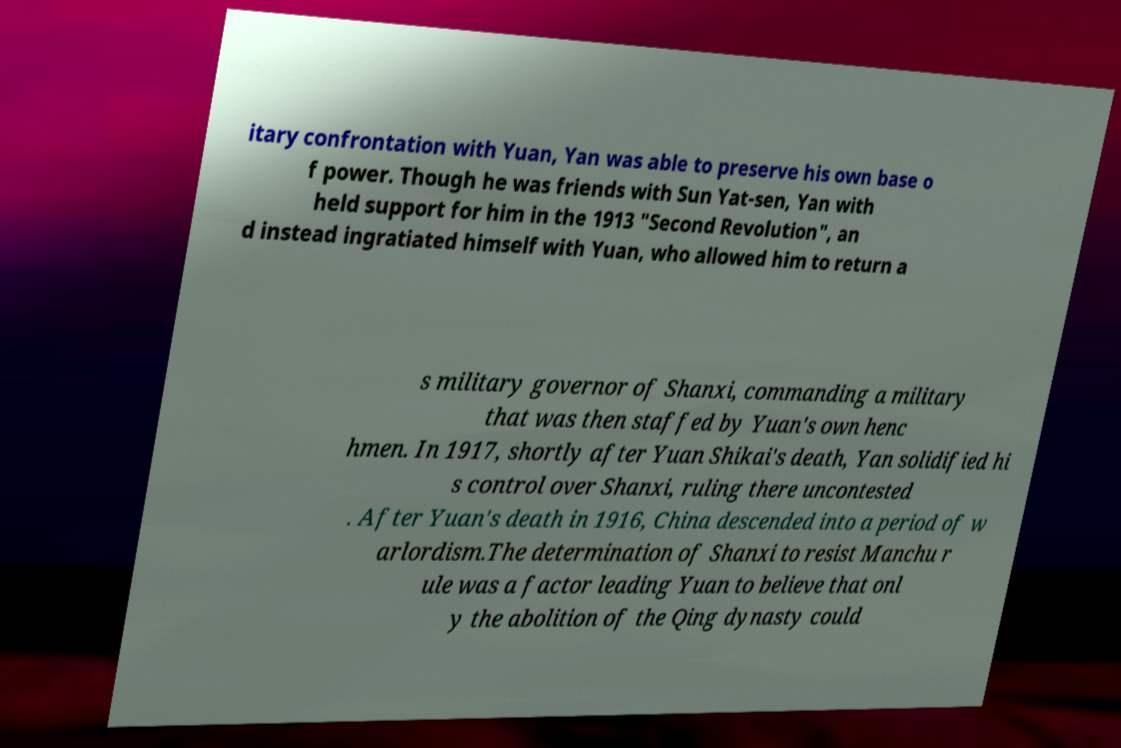There's text embedded in this image that I need extracted. Can you transcribe it verbatim? itary confrontation with Yuan, Yan was able to preserve his own base o f power. Though he was friends with Sun Yat-sen, Yan with held support for him in the 1913 "Second Revolution", an d instead ingratiated himself with Yuan, who allowed him to return a s military governor of Shanxi, commanding a military that was then staffed by Yuan's own henc hmen. In 1917, shortly after Yuan Shikai's death, Yan solidified hi s control over Shanxi, ruling there uncontested . After Yuan's death in 1916, China descended into a period of w arlordism.The determination of Shanxi to resist Manchu r ule was a factor leading Yuan to believe that onl y the abolition of the Qing dynasty could 